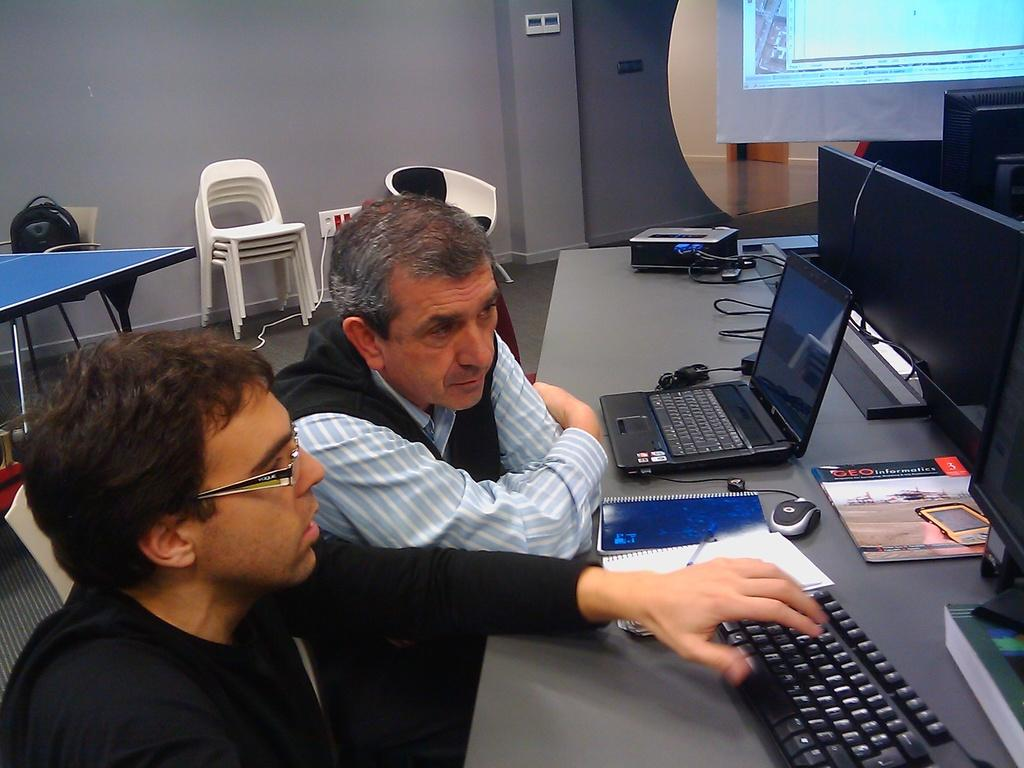How many people are sitting in the chair in the image? There are two people sitting in a chair in the image. What is in front of the people? There is a table in front of the people. What can be found on the table? The table consists of monitors, laptops, keyboards, mice, a book, and a pen. What type of liquid is being poured on the laptops in the image? There is no liquid being poured on the laptops in the image; the table consists of monitors, laptops, keyboards, mice, a book, and a pen. 